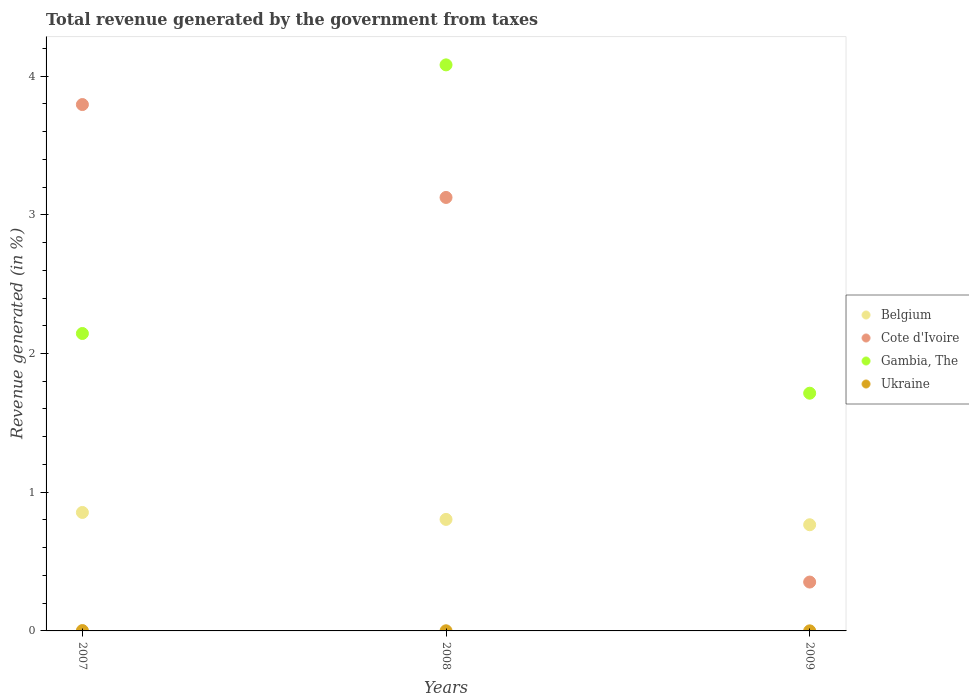How many different coloured dotlines are there?
Offer a very short reply. 4. What is the total revenue generated in Cote d'Ivoire in 2009?
Offer a very short reply. 0.35. Across all years, what is the maximum total revenue generated in Cote d'Ivoire?
Ensure brevity in your answer.  3.79. Across all years, what is the minimum total revenue generated in Belgium?
Give a very brief answer. 0.77. In which year was the total revenue generated in Ukraine minimum?
Offer a very short reply. 2009. What is the total total revenue generated in Gambia, The in the graph?
Provide a short and direct response. 7.94. What is the difference between the total revenue generated in Belgium in 2007 and that in 2008?
Provide a succinct answer. 0.05. What is the difference between the total revenue generated in Belgium in 2007 and the total revenue generated in Ukraine in 2008?
Provide a short and direct response. 0.85. What is the average total revenue generated in Ukraine per year?
Offer a very short reply. 0. In the year 2007, what is the difference between the total revenue generated in Belgium and total revenue generated in Ukraine?
Keep it short and to the point. 0.85. In how many years, is the total revenue generated in Belgium greater than 3.4 %?
Your answer should be very brief. 0. What is the ratio of the total revenue generated in Ukraine in 2007 to that in 2008?
Keep it short and to the point. 2.61. Is the total revenue generated in Belgium in 2007 less than that in 2009?
Your answer should be compact. No. What is the difference between the highest and the second highest total revenue generated in Cote d'Ivoire?
Your response must be concise. 0.67. What is the difference between the highest and the lowest total revenue generated in Gambia, The?
Offer a terse response. 2.37. In how many years, is the total revenue generated in Belgium greater than the average total revenue generated in Belgium taken over all years?
Your response must be concise. 1. Is it the case that in every year, the sum of the total revenue generated in Belgium and total revenue generated in Ukraine  is greater than the total revenue generated in Cote d'Ivoire?
Your answer should be compact. No. Does the total revenue generated in Ukraine monotonically increase over the years?
Provide a short and direct response. No. Is the total revenue generated in Cote d'Ivoire strictly greater than the total revenue generated in Gambia, The over the years?
Your answer should be very brief. No. Is the total revenue generated in Belgium strictly less than the total revenue generated in Ukraine over the years?
Give a very brief answer. No. How many dotlines are there?
Give a very brief answer. 4. What is the difference between two consecutive major ticks on the Y-axis?
Your answer should be compact. 1. What is the title of the graph?
Your response must be concise. Total revenue generated by the government from taxes. Does "Other small states" appear as one of the legend labels in the graph?
Offer a very short reply. No. What is the label or title of the X-axis?
Offer a very short reply. Years. What is the label or title of the Y-axis?
Ensure brevity in your answer.  Revenue generated (in %). What is the Revenue generated (in %) of Belgium in 2007?
Provide a succinct answer. 0.85. What is the Revenue generated (in %) in Cote d'Ivoire in 2007?
Your response must be concise. 3.79. What is the Revenue generated (in %) of Gambia, The in 2007?
Provide a short and direct response. 2.14. What is the Revenue generated (in %) in Ukraine in 2007?
Make the answer very short. 0. What is the Revenue generated (in %) in Belgium in 2008?
Your answer should be very brief. 0.8. What is the Revenue generated (in %) in Cote d'Ivoire in 2008?
Offer a terse response. 3.13. What is the Revenue generated (in %) in Gambia, The in 2008?
Keep it short and to the point. 4.08. What is the Revenue generated (in %) in Ukraine in 2008?
Provide a short and direct response. 0. What is the Revenue generated (in %) in Belgium in 2009?
Your response must be concise. 0.77. What is the Revenue generated (in %) of Cote d'Ivoire in 2009?
Your answer should be very brief. 0.35. What is the Revenue generated (in %) of Gambia, The in 2009?
Offer a terse response. 1.71. What is the Revenue generated (in %) of Ukraine in 2009?
Your answer should be very brief. 0. Across all years, what is the maximum Revenue generated (in %) of Belgium?
Your answer should be compact. 0.85. Across all years, what is the maximum Revenue generated (in %) of Cote d'Ivoire?
Keep it short and to the point. 3.79. Across all years, what is the maximum Revenue generated (in %) in Gambia, The?
Ensure brevity in your answer.  4.08. Across all years, what is the maximum Revenue generated (in %) of Ukraine?
Give a very brief answer. 0. Across all years, what is the minimum Revenue generated (in %) in Belgium?
Keep it short and to the point. 0.77. Across all years, what is the minimum Revenue generated (in %) of Cote d'Ivoire?
Offer a terse response. 0.35. Across all years, what is the minimum Revenue generated (in %) of Gambia, The?
Ensure brevity in your answer.  1.71. Across all years, what is the minimum Revenue generated (in %) of Ukraine?
Provide a short and direct response. 0. What is the total Revenue generated (in %) in Belgium in the graph?
Give a very brief answer. 2.42. What is the total Revenue generated (in %) in Cote d'Ivoire in the graph?
Provide a short and direct response. 7.27. What is the total Revenue generated (in %) in Gambia, The in the graph?
Provide a short and direct response. 7.94. What is the total Revenue generated (in %) in Ukraine in the graph?
Ensure brevity in your answer.  0. What is the difference between the Revenue generated (in %) of Belgium in 2007 and that in 2008?
Provide a succinct answer. 0.05. What is the difference between the Revenue generated (in %) in Cote d'Ivoire in 2007 and that in 2008?
Your answer should be compact. 0.67. What is the difference between the Revenue generated (in %) in Gambia, The in 2007 and that in 2008?
Offer a terse response. -1.94. What is the difference between the Revenue generated (in %) of Ukraine in 2007 and that in 2008?
Give a very brief answer. 0. What is the difference between the Revenue generated (in %) of Belgium in 2007 and that in 2009?
Your response must be concise. 0.09. What is the difference between the Revenue generated (in %) of Cote d'Ivoire in 2007 and that in 2009?
Your answer should be compact. 3.44. What is the difference between the Revenue generated (in %) in Gambia, The in 2007 and that in 2009?
Make the answer very short. 0.43. What is the difference between the Revenue generated (in %) in Ukraine in 2007 and that in 2009?
Offer a very short reply. 0. What is the difference between the Revenue generated (in %) in Belgium in 2008 and that in 2009?
Your answer should be compact. 0.04. What is the difference between the Revenue generated (in %) of Cote d'Ivoire in 2008 and that in 2009?
Make the answer very short. 2.77. What is the difference between the Revenue generated (in %) in Gambia, The in 2008 and that in 2009?
Your response must be concise. 2.37. What is the difference between the Revenue generated (in %) in Belgium in 2007 and the Revenue generated (in %) in Cote d'Ivoire in 2008?
Your answer should be very brief. -2.27. What is the difference between the Revenue generated (in %) of Belgium in 2007 and the Revenue generated (in %) of Gambia, The in 2008?
Give a very brief answer. -3.23. What is the difference between the Revenue generated (in %) in Belgium in 2007 and the Revenue generated (in %) in Ukraine in 2008?
Your answer should be compact. 0.85. What is the difference between the Revenue generated (in %) of Cote d'Ivoire in 2007 and the Revenue generated (in %) of Gambia, The in 2008?
Offer a terse response. -0.29. What is the difference between the Revenue generated (in %) of Cote d'Ivoire in 2007 and the Revenue generated (in %) of Ukraine in 2008?
Keep it short and to the point. 3.79. What is the difference between the Revenue generated (in %) in Gambia, The in 2007 and the Revenue generated (in %) in Ukraine in 2008?
Your answer should be compact. 2.14. What is the difference between the Revenue generated (in %) in Belgium in 2007 and the Revenue generated (in %) in Cote d'Ivoire in 2009?
Your response must be concise. 0.5. What is the difference between the Revenue generated (in %) in Belgium in 2007 and the Revenue generated (in %) in Gambia, The in 2009?
Offer a very short reply. -0.86. What is the difference between the Revenue generated (in %) in Belgium in 2007 and the Revenue generated (in %) in Ukraine in 2009?
Provide a succinct answer. 0.85. What is the difference between the Revenue generated (in %) of Cote d'Ivoire in 2007 and the Revenue generated (in %) of Gambia, The in 2009?
Ensure brevity in your answer.  2.08. What is the difference between the Revenue generated (in %) of Cote d'Ivoire in 2007 and the Revenue generated (in %) of Ukraine in 2009?
Your response must be concise. 3.79. What is the difference between the Revenue generated (in %) in Gambia, The in 2007 and the Revenue generated (in %) in Ukraine in 2009?
Provide a short and direct response. 2.14. What is the difference between the Revenue generated (in %) in Belgium in 2008 and the Revenue generated (in %) in Cote d'Ivoire in 2009?
Make the answer very short. 0.45. What is the difference between the Revenue generated (in %) of Belgium in 2008 and the Revenue generated (in %) of Gambia, The in 2009?
Your answer should be very brief. -0.91. What is the difference between the Revenue generated (in %) in Belgium in 2008 and the Revenue generated (in %) in Ukraine in 2009?
Offer a very short reply. 0.8. What is the difference between the Revenue generated (in %) of Cote d'Ivoire in 2008 and the Revenue generated (in %) of Gambia, The in 2009?
Provide a short and direct response. 1.41. What is the difference between the Revenue generated (in %) in Cote d'Ivoire in 2008 and the Revenue generated (in %) in Ukraine in 2009?
Give a very brief answer. 3.12. What is the difference between the Revenue generated (in %) of Gambia, The in 2008 and the Revenue generated (in %) of Ukraine in 2009?
Provide a succinct answer. 4.08. What is the average Revenue generated (in %) of Belgium per year?
Ensure brevity in your answer.  0.81. What is the average Revenue generated (in %) in Cote d'Ivoire per year?
Your answer should be compact. 2.42. What is the average Revenue generated (in %) in Gambia, The per year?
Provide a short and direct response. 2.65. What is the average Revenue generated (in %) of Ukraine per year?
Offer a terse response. 0. In the year 2007, what is the difference between the Revenue generated (in %) of Belgium and Revenue generated (in %) of Cote d'Ivoire?
Your response must be concise. -2.94. In the year 2007, what is the difference between the Revenue generated (in %) in Belgium and Revenue generated (in %) in Gambia, The?
Make the answer very short. -1.29. In the year 2007, what is the difference between the Revenue generated (in %) of Belgium and Revenue generated (in %) of Ukraine?
Keep it short and to the point. 0.85. In the year 2007, what is the difference between the Revenue generated (in %) in Cote d'Ivoire and Revenue generated (in %) in Gambia, The?
Give a very brief answer. 1.65. In the year 2007, what is the difference between the Revenue generated (in %) in Cote d'Ivoire and Revenue generated (in %) in Ukraine?
Offer a terse response. 3.79. In the year 2007, what is the difference between the Revenue generated (in %) in Gambia, The and Revenue generated (in %) in Ukraine?
Give a very brief answer. 2.14. In the year 2008, what is the difference between the Revenue generated (in %) in Belgium and Revenue generated (in %) in Cote d'Ivoire?
Give a very brief answer. -2.32. In the year 2008, what is the difference between the Revenue generated (in %) of Belgium and Revenue generated (in %) of Gambia, The?
Offer a terse response. -3.28. In the year 2008, what is the difference between the Revenue generated (in %) of Belgium and Revenue generated (in %) of Ukraine?
Offer a terse response. 0.8. In the year 2008, what is the difference between the Revenue generated (in %) of Cote d'Ivoire and Revenue generated (in %) of Gambia, The?
Your answer should be compact. -0.96. In the year 2008, what is the difference between the Revenue generated (in %) in Cote d'Ivoire and Revenue generated (in %) in Ukraine?
Make the answer very short. 3.12. In the year 2008, what is the difference between the Revenue generated (in %) in Gambia, The and Revenue generated (in %) in Ukraine?
Provide a short and direct response. 4.08. In the year 2009, what is the difference between the Revenue generated (in %) in Belgium and Revenue generated (in %) in Cote d'Ivoire?
Offer a very short reply. 0.41. In the year 2009, what is the difference between the Revenue generated (in %) in Belgium and Revenue generated (in %) in Gambia, The?
Your answer should be very brief. -0.95. In the year 2009, what is the difference between the Revenue generated (in %) in Belgium and Revenue generated (in %) in Ukraine?
Provide a succinct answer. 0.76. In the year 2009, what is the difference between the Revenue generated (in %) of Cote d'Ivoire and Revenue generated (in %) of Gambia, The?
Make the answer very short. -1.36. In the year 2009, what is the difference between the Revenue generated (in %) of Cote d'Ivoire and Revenue generated (in %) of Ukraine?
Make the answer very short. 0.35. In the year 2009, what is the difference between the Revenue generated (in %) in Gambia, The and Revenue generated (in %) in Ukraine?
Your answer should be compact. 1.71. What is the ratio of the Revenue generated (in %) in Belgium in 2007 to that in 2008?
Give a very brief answer. 1.06. What is the ratio of the Revenue generated (in %) of Cote d'Ivoire in 2007 to that in 2008?
Provide a short and direct response. 1.21. What is the ratio of the Revenue generated (in %) in Gambia, The in 2007 to that in 2008?
Ensure brevity in your answer.  0.53. What is the ratio of the Revenue generated (in %) in Ukraine in 2007 to that in 2008?
Offer a terse response. 2.61. What is the ratio of the Revenue generated (in %) of Belgium in 2007 to that in 2009?
Ensure brevity in your answer.  1.12. What is the ratio of the Revenue generated (in %) of Cote d'Ivoire in 2007 to that in 2009?
Provide a short and direct response. 10.77. What is the ratio of the Revenue generated (in %) of Gambia, The in 2007 to that in 2009?
Offer a terse response. 1.25. What is the ratio of the Revenue generated (in %) in Ukraine in 2007 to that in 2009?
Your response must be concise. 4.65. What is the ratio of the Revenue generated (in %) of Belgium in 2008 to that in 2009?
Ensure brevity in your answer.  1.05. What is the ratio of the Revenue generated (in %) of Cote d'Ivoire in 2008 to that in 2009?
Ensure brevity in your answer.  8.87. What is the ratio of the Revenue generated (in %) in Gambia, The in 2008 to that in 2009?
Offer a very short reply. 2.38. What is the ratio of the Revenue generated (in %) in Ukraine in 2008 to that in 2009?
Your response must be concise. 1.78. What is the difference between the highest and the second highest Revenue generated (in %) in Belgium?
Offer a terse response. 0.05. What is the difference between the highest and the second highest Revenue generated (in %) of Cote d'Ivoire?
Give a very brief answer. 0.67. What is the difference between the highest and the second highest Revenue generated (in %) in Gambia, The?
Make the answer very short. 1.94. What is the difference between the highest and the second highest Revenue generated (in %) in Ukraine?
Ensure brevity in your answer.  0. What is the difference between the highest and the lowest Revenue generated (in %) in Belgium?
Ensure brevity in your answer.  0.09. What is the difference between the highest and the lowest Revenue generated (in %) in Cote d'Ivoire?
Give a very brief answer. 3.44. What is the difference between the highest and the lowest Revenue generated (in %) of Gambia, The?
Your answer should be very brief. 2.37. What is the difference between the highest and the lowest Revenue generated (in %) of Ukraine?
Make the answer very short. 0. 